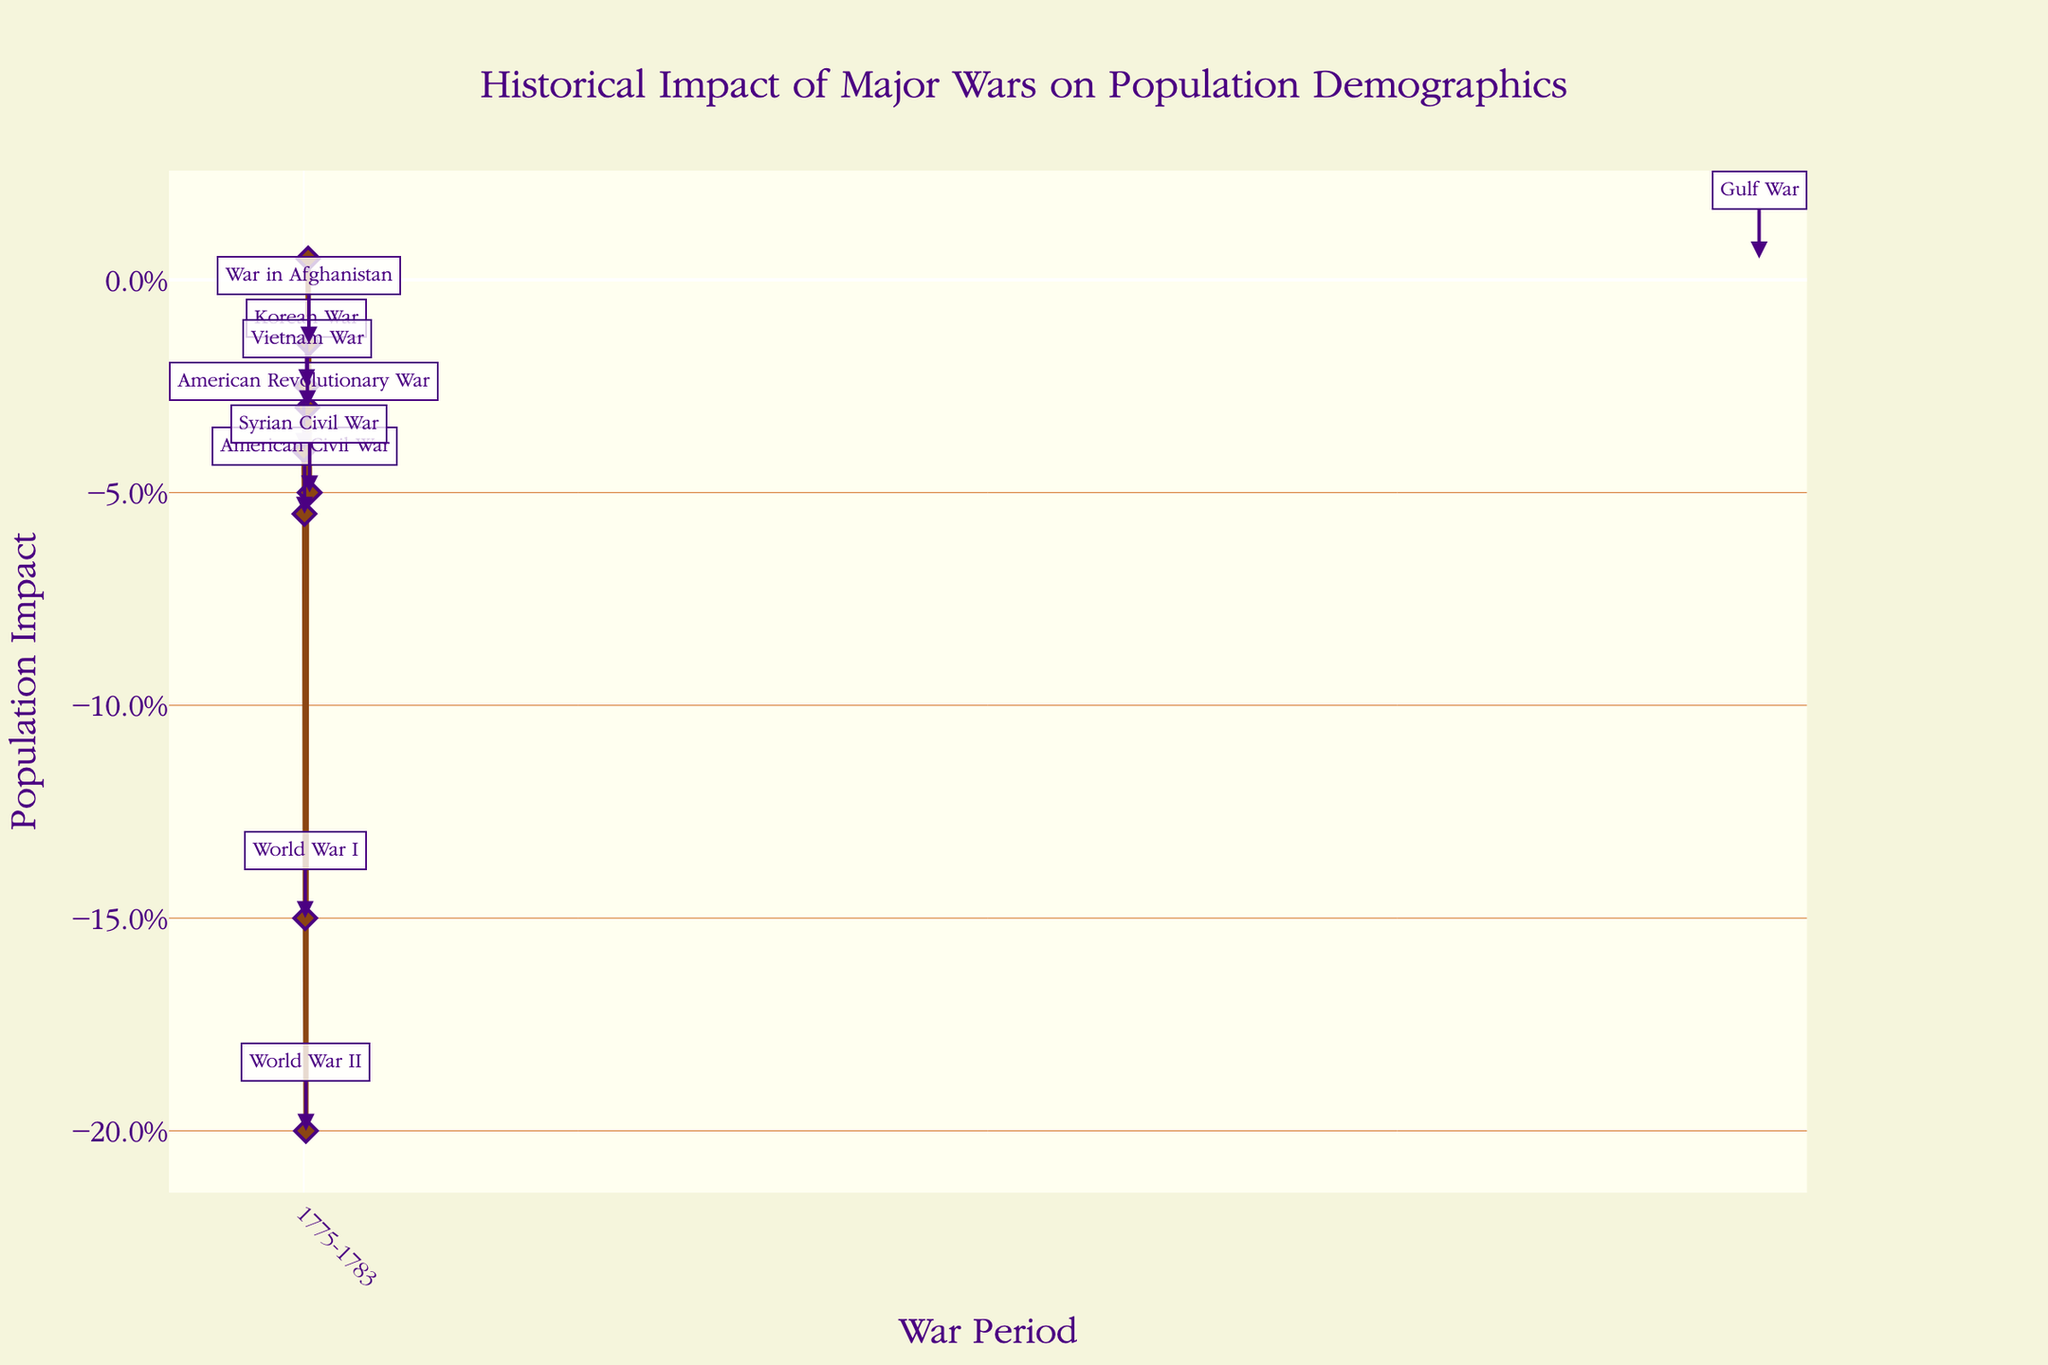What's the title of the figure? The title of the figure is prominently displayed at the top in a larger font size, denoting what the figure represents.
Answer: Historical Impact of Major Wars on Population Demographics How does the population impact of World War II compare to World War I? By observing the y-axis values and the annotations, World War II has a population impact of -0.200 while World War I has a population impact of -0.150.
Answer: World War II had a greater negative impact What is the period of the war with the lowest population impact? The war period with the positive impact can be identified by looking for the highest point above the baseline on the y-axis. This is the Gulf War with a population impact of +0.005.
Answer: Gulf War (1991) Which war caused the smallest decrease in population? Examining the points closest to the baseline in the negative region, the Korean War (1950-1953) had the smallest decrease with -0.025.
Answer: Korean War What are the y-axis units used to measure population impact? The y-axis represents population impact in percentage format, indicated by the '%' symbol next to the numeric axis values.
Answer: Percentage List the wars from highest to lowest population impact. Sorting the annotated points by their y-axis values (population impact), the order from highest to lowest is: Gulf War (+0.005), War in Afghanistan (-0.015), Vietnam War (-0.030), Syrian Civil War (-0.050), American Civil War (-0.055), American Revolutionary War (-0.040), Korean War (-0.025), World War I (-0.150), World War II (-0.200).
Answer: Gulf War, War in Afghanistan, Vietnam War, Syrian Civil War, American Civil War, American Revolutionary War, Korean War, World War I, World War II What trend do you see in population impact from the World Wars to recent conflicts? Observing the y-axis values from World War I and World War II and comparing them to more recent conflicts like the War in Afghanistan and the Syrian Civil War, there is a general trend towards lower negative population impacts in more recent conflicts.
Answer: Decreasing negative impact How does the impact of the Korean War compare to the Vietnam War? Looking at the y-axis values, the Korean War had a population impact of -0.025, while the Vietnam War had a population impact of -0.030.
Answer: Korean War had a smaller negative impact Which war lasted the longest according to the x-axis? The duration can be gauged by the length of the war period mentioned in the x-axis. The War in Afghanistan (2001-2021) lasted the longest, spanning 20 years.
Answer: War in Afghanistan 